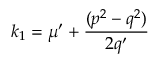<formula> <loc_0><loc_0><loc_500><loc_500>k _ { 1 } = \mu ^ { \prime } + \frac { ( p ^ { 2 } - q ^ { 2 } ) } { 2 q ^ { \prime } }</formula> 